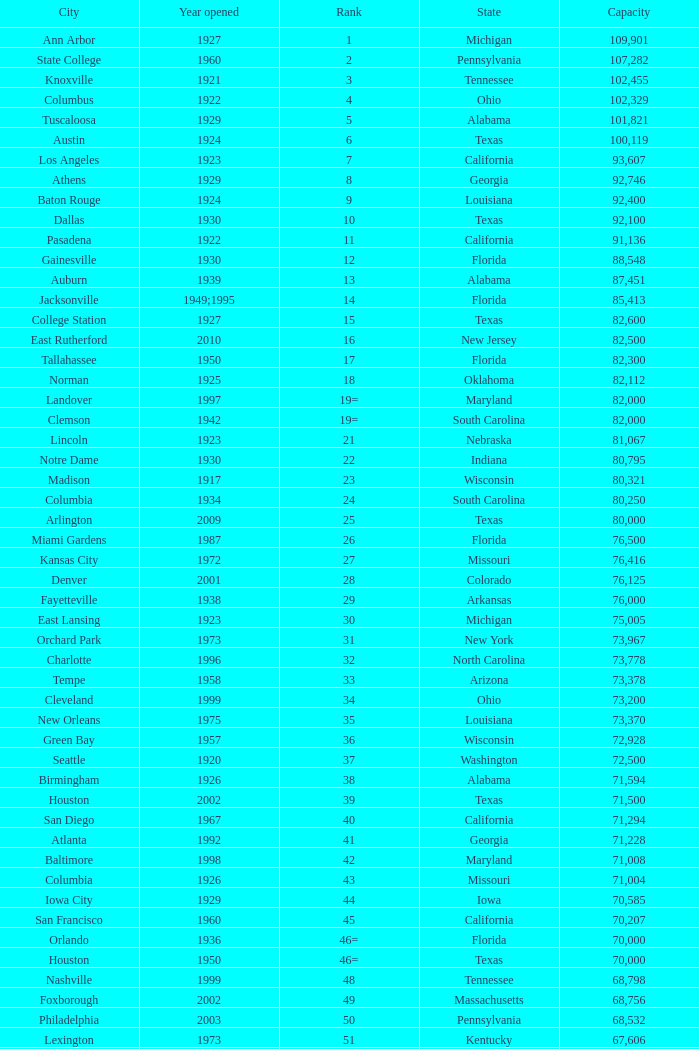What is the lowest capacity for 1903? 30323.0. 